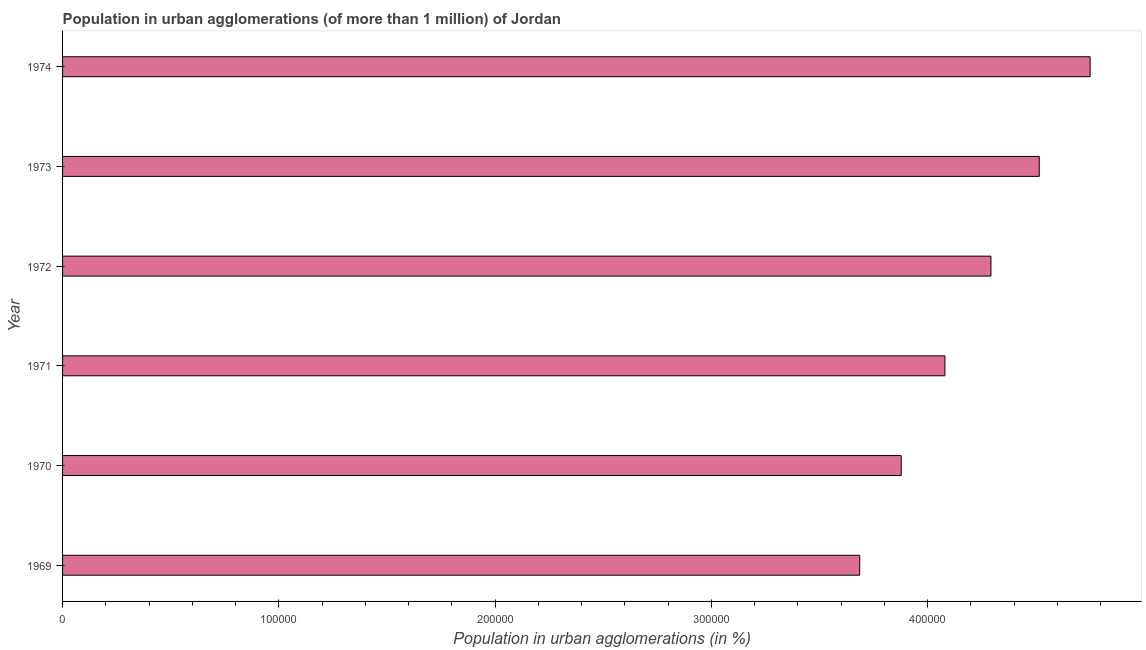Does the graph contain any zero values?
Ensure brevity in your answer.  No. What is the title of the graph?
Keep it short and to the point. Population in urban agglomerations (of more than 1 million) of Jordan. What is the label or title of the X-axis?
Provide a short and direct response. Population in urban agglomerations (in %). What is the label or title of the Y-axis?
Ensure brevity in your answer.  Year. What is the population in urban agglomerations in 1970?
Give a very brief answer. 3.88e+05. Across all years, what is the maximum population in urban agglomerations?
Make the answer very short. 4.75e+05. Across all years, what is the minimum population in urban agglomerations?
Give a very brief answer. 3.69e+05. In which year was the population in urban agglomerations maximum?
Your response must be concise. 1974. In which year was the population in urban agglomerations minimum?
Give a very brief answer. 1969. What is the sum of the population in urban agglomerations?
Your response must be concise. 2.52e+06. What is the difference between the population in urban agglomerations in 1970 and 1973?
Your answer should be compact. -6.38e+04. What is the average population in urban agglomerations per year?
Your answer should be compact. 4.20e+05. What is the median population in urban agglomerations?
Make the answer very short. 4.19e+05. In how many years, is the population in urban agglomerations greater than 180000 %?
Provide a succinct answer. 6. Do a majority of the years between 1974 and 1970 (inclusive) have population in urban agglomerations greater than 80000 %?
Provide a short and direct response. Yes. Is the population in urban agglomerations in 1969 less than that in 1970?
Your answer should be very brief. Yes. What is the difference between the highest and the second highest population in urban agglomerations?
Give a very brief answer. 2.35e+04. What is the difference between the highest and the lowest population in urban agglomerations?
Offer a very short reply. 1.07e+05. How many years are there in the graph?
Your response must be concise. 6. What is the difference between two consecutive major ticks on the X-axis?
Your response must be concise. 1.00e+05. Are the values on the major ticks of X-axis written in scientific E-notation?
Make the answer very short. No. What is the Population in urban agglomerations (in %) of 1969?
Ensure brevity in your answer.  3.69e+05. What is the Population in urban agglomerations (in %) in 1970?
Provide a short and direct response. 3.88e+05. What is the Population in urban agglomerations (in %) in 1971?
Provide a short and direct response. 4.08e+05. What is the Population in urban agglomerations (in %) of 1972?
Ensure brevity in your answer.  4.29e+05. What is the Population in urban agglomerations (in %) of 1973?
Give a very brief answer. 4.52e+05. What is the Population in urban agglomerations (in %) in 1974?
Keep it short and to the point. 4.75e+05. What is the difference between the Population in urban agglomerations (in %) in 1969 and 1970?
Offer a terse response. -1.92e+04. What is the difference between the Population in urban agglomerations (in %) in 1969 and 1971?
Make the answer very short. -3.94e+04. What is the difference between the Population in urban agglomerations (in %) in 1969 and 1972?
Provide a short and direct response. -6.07e+04. What is the difference between the Population in urban agglomerations (in %) in 1969 and 1973?
Provide a succinct answer. -8.30e+04. What is the difference between the Population in urban agglomerations (in %) in 1969 and 1974?
Your answer should be compact. -1.07e+05. What is the difference between the Population in urban agglomerations (in %) in 1970 and 1971?
Give a very brief answer. -2.02e+04. What is the difference between the Population in urban agglomerations (in %) in 1970 and 1972?
Provide a succinct answer. -4.15e+04. What is the difference between the Population in urban agglomerations (in %) in 1970 and 1973?
Your response must be concise. -6.38e+04. What is the difference between the Population in urban agglomerations (in %) in 1970 and 1974?
Provide a succinct answer. -8.74e+04. What is the difference between the Population in urban agglomerations (in %) in 1971 and 1972?
Make the answer very short. -2.13e+04. What is the difference between the Population in urban agglomerations (in %) in 1971 and 1973?
Keep it short and to the point. -4.36e+04. What is the difference between the Population in urban agglomerations (in %) in 1971 and 1974?
Give a very brief answer. -6.72e+04. What is the difference between the Population in urban agglomerations (in %) in 1972 and 1973?
Provide a short and direct response. -2.23e+04. What is the difference between the Population in urban agglomerations (in %) in 1972 and 1974?
Give a very brief answer. -4.59e+04. What is the difference between the Population in urban agglomerations (in %) in 1973 and 1974?
Your answer should be compact. -2.35e+04. What is the ratio of the Population in urban agglomerations (in %) in 1969 to that in 1971?
Your answer should be very brief. 0.9. What is the ratio of the Population in urban agglomerations (in %) in 1969 to that in 1972?
Your answer should be very brief. 0.86. What is the ratio of the Population in urban agglomerations (in %) in 1969 to that in 1973?
Offer a very short reply. 0.82. What is the ratio of the Population in urban agglomerations (in %) in 1969 to that in 1974?
Keep it short and to the point. 0.78. What is the ratio of the Population in urban agglomerations (in %) in 1970 to that in 1971?
Make the answer very short. 0.95. What is the ratio of the Population in urban agglomerations (in %) in 1970 to that in 1972?
Ensure brevity in your answer.  0.9. What is the ratio of the Population in urban agglomerations (in %) in 1970 to that in 1973?
Offer a very short reply. 0.86. What is the ratio of the Population in urban agglomerations (in %) in 1970 to that in 1974?
Your answer should be very brief. 0.82. What is the ratio of the Population in urban agglomerations (in %) in 1971 to that in 1973?
Your response must be concise. 0.9. What is the ratio of the Population in urban agglomerations (in %) in 1971 to that in 1974?
Your answer should be compact. 0.86. What is the ratio of the Population in urban agglomerations (in %) in 1972 to that in 1973?
Offer a terse response. 0.95. What is the ratio of the Population in urban agglomerations (in %) in 1972 to that in 1974?
Offer a very short reply. 0.9. 